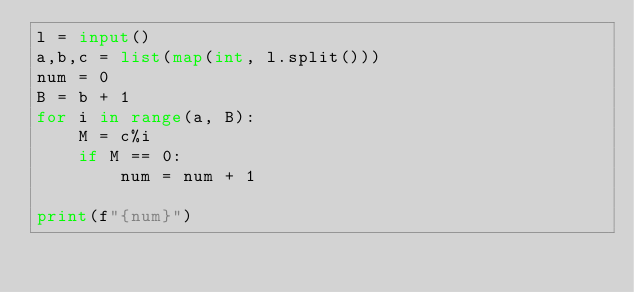Convert code to text. <code><loc_0><loc_0><loc_500><loc_500><_Python_>l = input()
a,b,c = list(map(int, l.split()))
num = 0
B = b + 1
for i in range(a, B):
    M = c%i
    if M == 0:
        num = num + 1
    
print(f"{num}")
</code> 